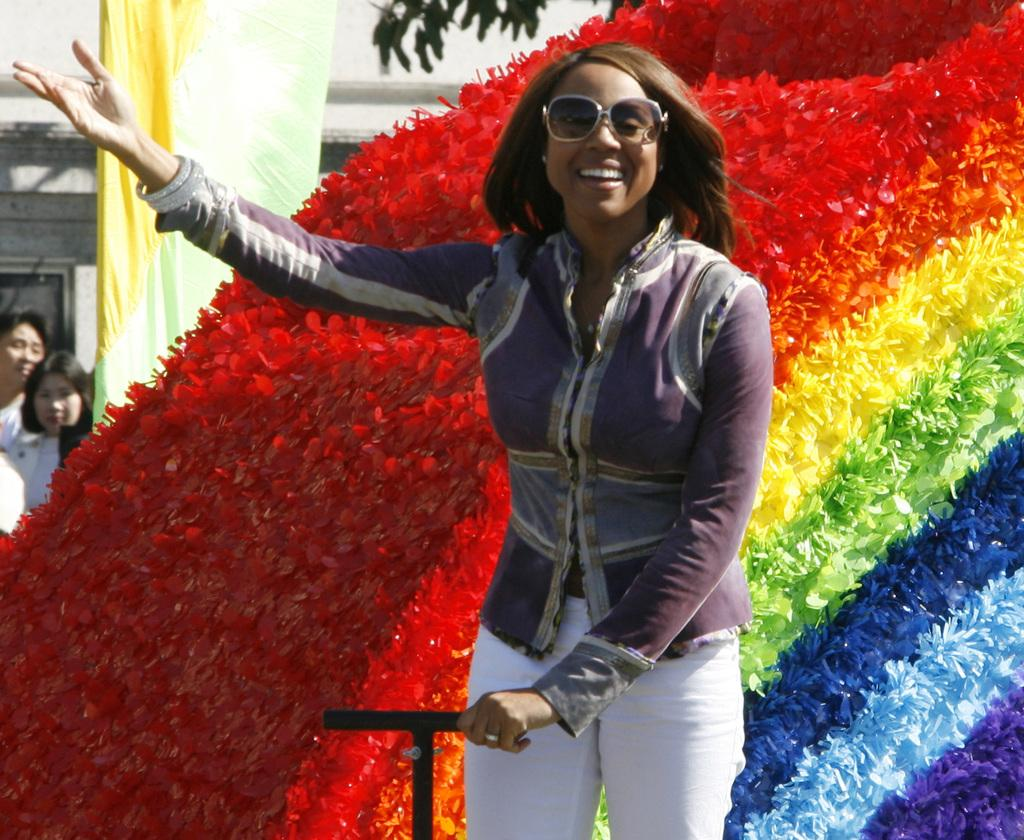Who is present in the image? There is a woman in the image. What is the woman doing in the image? The woman is smiling in the image. What is the woman wearing in the image? The woman is wearing goggles in the image. What can be seen in the background of the image? There is an object, two women, a banner, and a wall in the background of the image. What type of holiday is being celebrated in the garden in the image? There is no garden or holiday present in the image. 